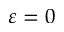<formula> <loc_0><loc_0><loc_500><loc_500>\varepsilon = 0</formula> 